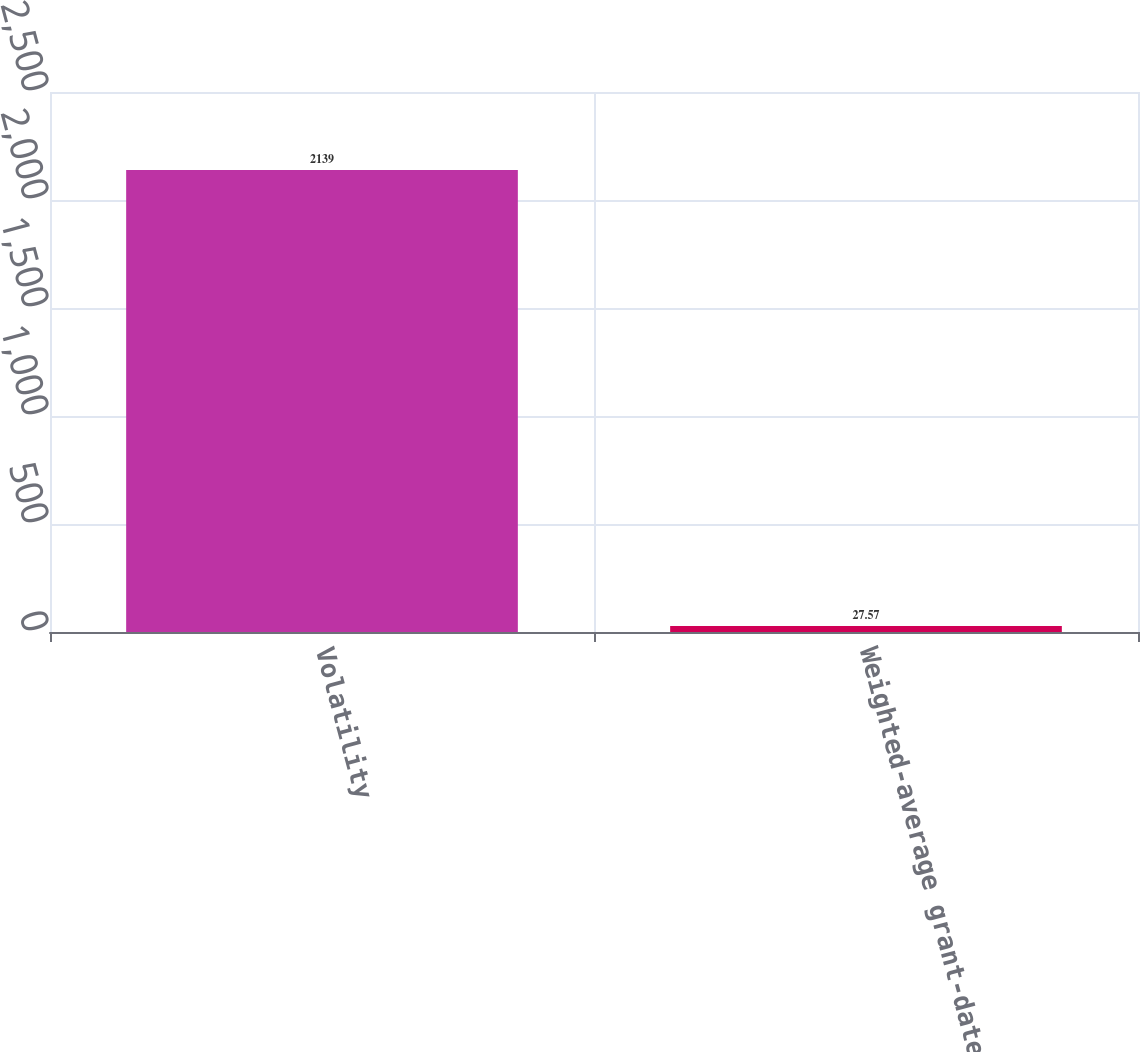Convert chart. <chart><loc_0><loc_0><loc_500><loc_500><bar_chart><fcel>Volatility<fcel>Weighted-average grant-date<nl><fcel>2139<fcel>27.57<nl></chart> 